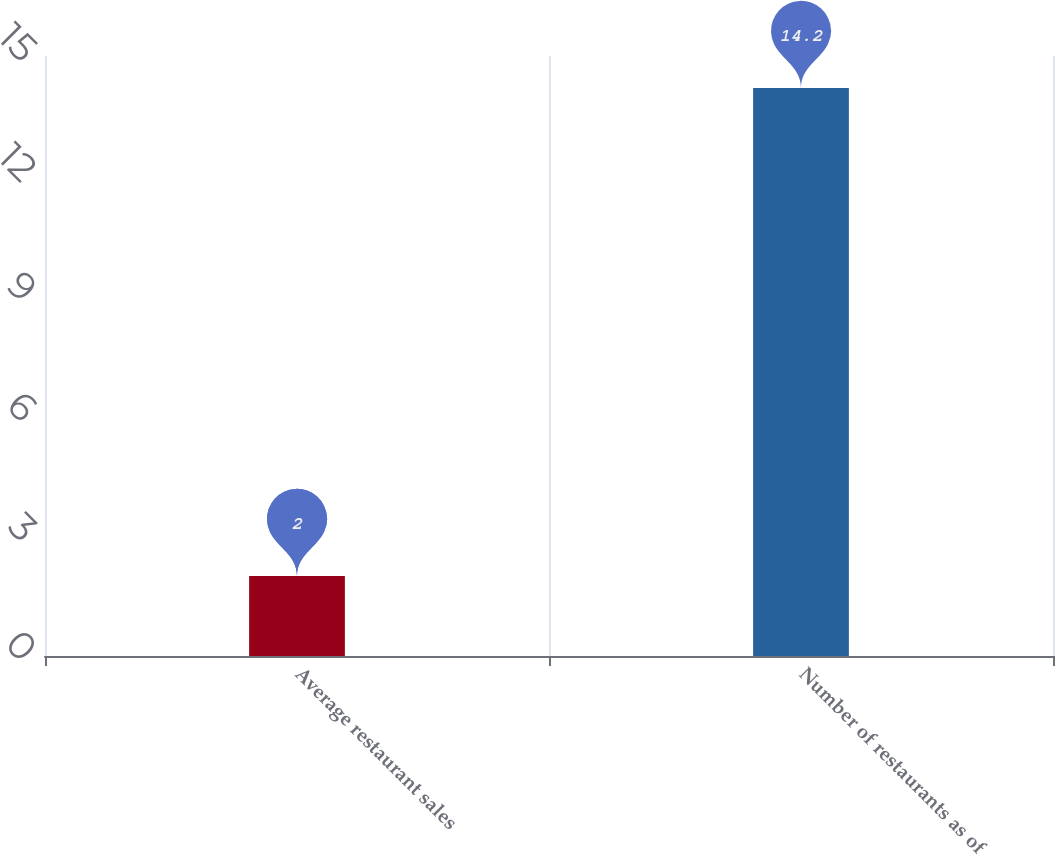Convert chart. <chart><loc_0><loc_0><loc_500><loc_500><bar_chart><fcel>Average restaurant sales<fcel>Number of restaurants as of<nl><fcel>2<fcel>14.2<nl></chart> 